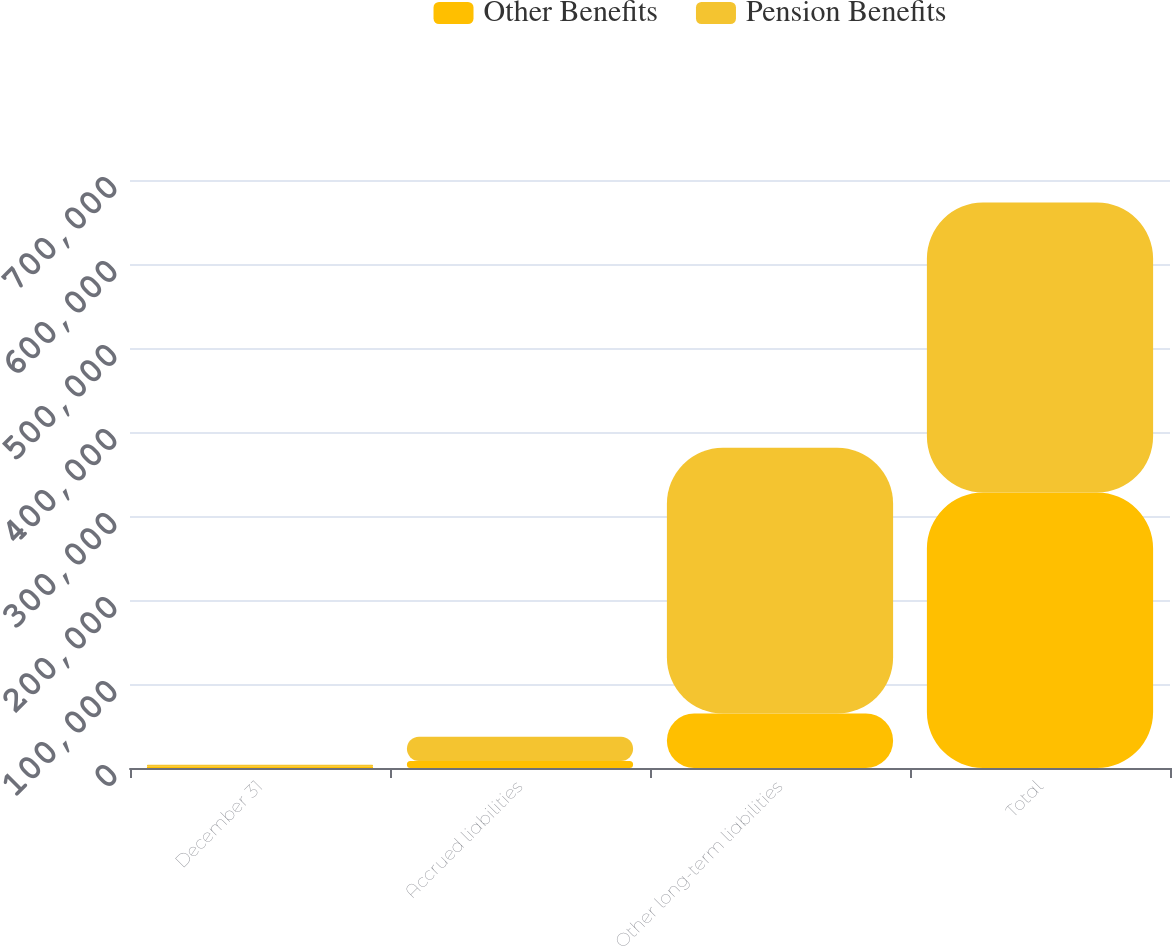Convert chart to OTSL. <chart><loc_0><loc_0><loc_500><loc_500><stacked_bar_chart><ecel><fcel>December 31<fcel>Accrued liabilities<fcel>Other long-term liabilities<fcel>Total<nl><fcel>Other Benefits<fcel>2006<fcel>8416<fcel>64824<fcel>327959<nl><fcel>Pension Benefits<fcel>2006<fcel>28746<fcel>316401<fcel>345147<nl></chart> 